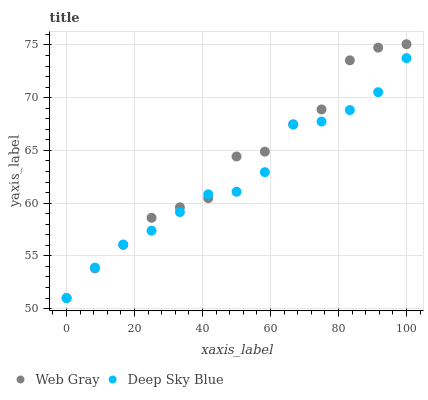Does Deep Sky Blue have the minimum area under the curve?
Answer yes or no. Yes. Does Web Gray have the maximum area under the curve?
Answer yes or no. Yes. Does Deep Sky Blue have the maximum area under the curve?
Answer yes or no. No. Is Deep Sky Blue the smoothest?
Answer yes or no. Yes. Is Web Gray the roughest?
Answer yes or no. Yes. Is Deep Sky Blue the roughest?
Answer yes or no. No. Does Web Gray have the lowest value?
Answer yes or no. Yes. Does Web Gray have the highest value?
Answer yes or no. Yes. Does Deep Sky Blue have the highest value?
Answer yes or no. No. Does Web Gray intersect Deep Sky Blue?
Answer yes or no. Yes. Is Web Gray less than Deep Sky Blue?
Answer yes or no. No. Is Web Gray greater than Deep Sky Blue?
Answer yes or no. No. 